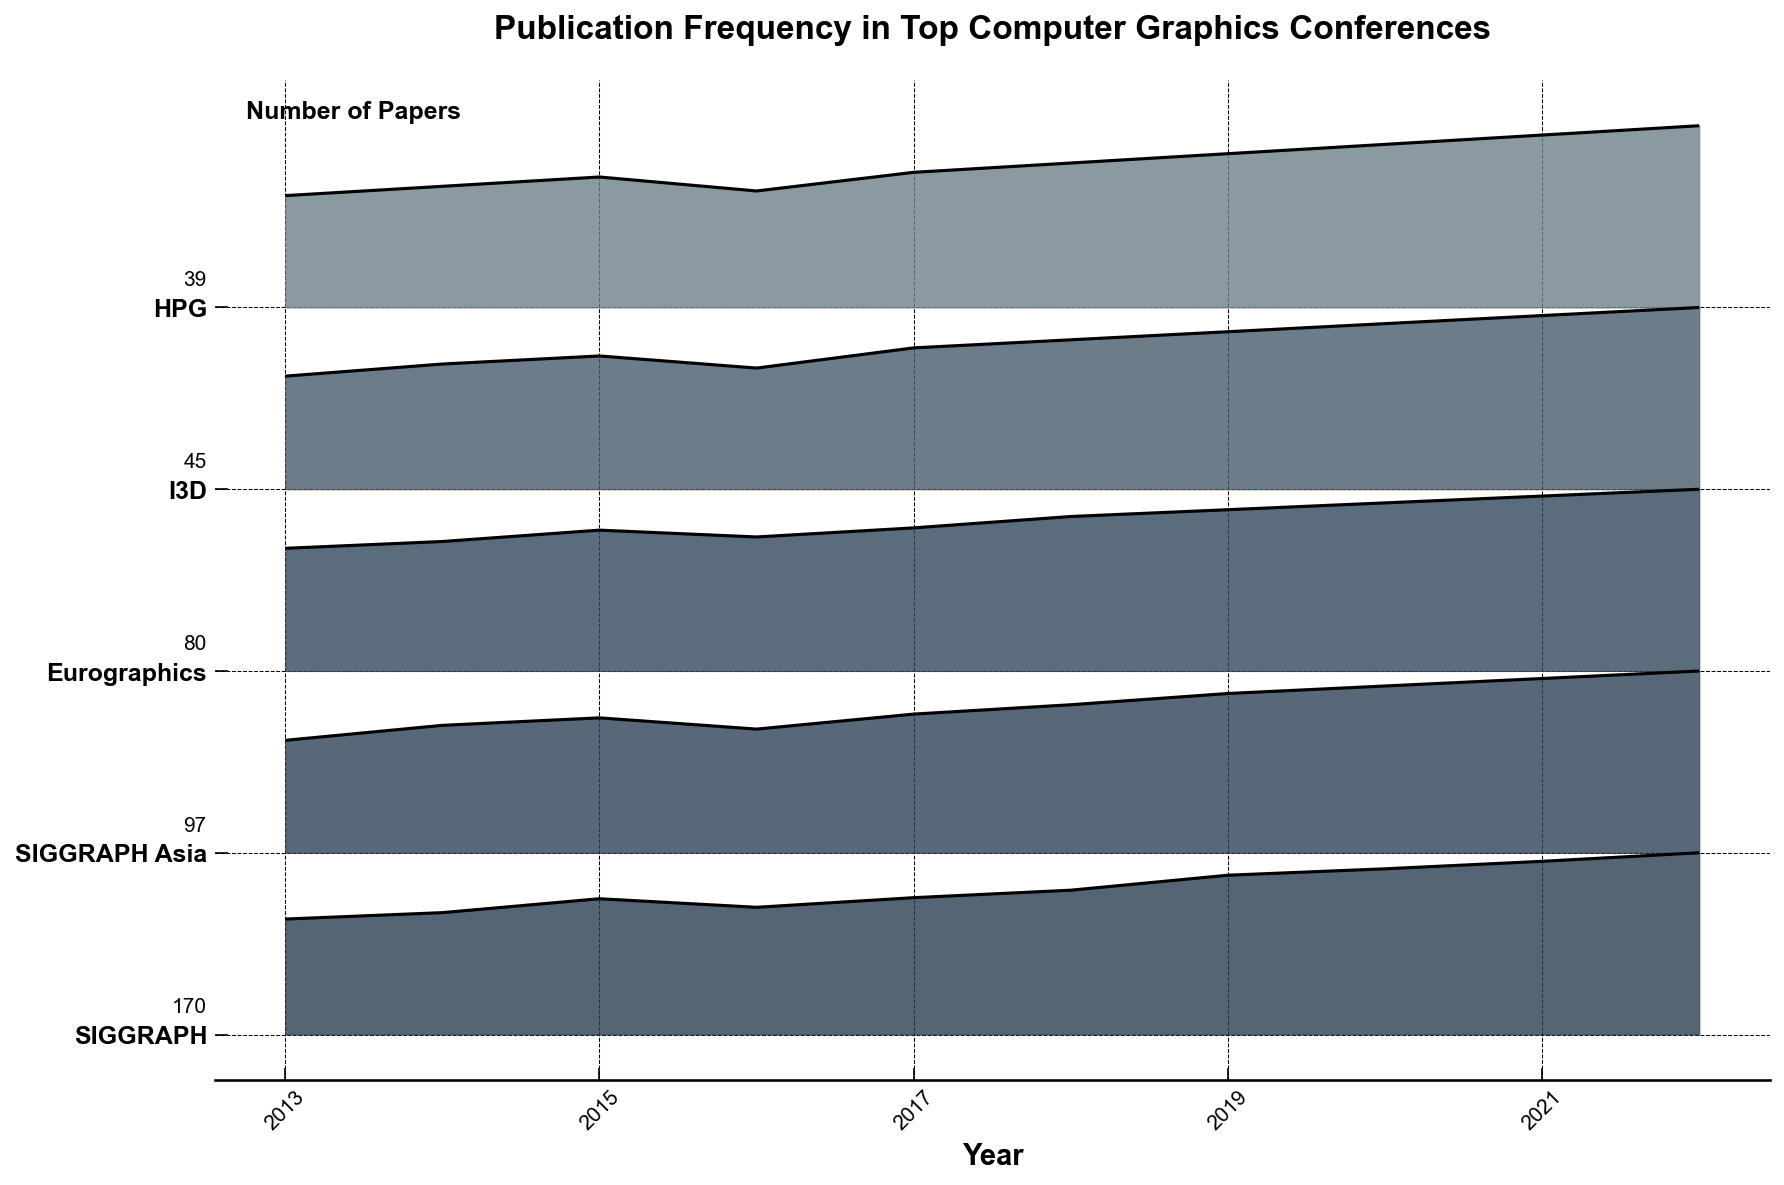Which conference has the highest number of publications in 2022? Look for the highest point on the 2022 axis and identify its corresponding conference from the y-axis labels.
Answer: SIGGRAPH How does the publication trend of Eurographics compare to SIGGRAPH over the years? Observe the peaks and valleys in the filled areas for both Eurographics and SIGGRAPH and note their changes over the years.
Answer: SIGGRAPH has a consistently higher and rising trend compared to Eurographics Which year did I3D have the highest number of publications? Identify the peak point in the I3D ridge and trace it down to the corresponding year on the x-axis.
Answer: 2022 What is the approximate difference in the number of publications between SIGGRAPH and HPG in 2021? Check the heights of the ridges for both SIGGRAPH and HPG in the year 2021 and subtract the smaller value from the larger value.
Answer: 125 Which two conferences had the closest number of publications in 2014? Compare the heights of the ridges for all conferences in 2014 and identify the two that visually appear closest to each other.
Answer: I3D and HPG Which conference shows a consistent increase in publications every year from 2013 to 2022? Look for the ridge that continuously increases without any decrease over the years.
Answer: SIGGRAPH How many years have SIGGRAPH Asia and Eurographics had the same number of publications? Visually scan the ridges of SIGGRAPH Asia and Eurographics and count the years where their peaks match.
Answer: 0 What was the combined total number of publications at HPG and I3D in 2020? Identify and add the number of publications for HPG and I3D in 2020.
Answer: 76 